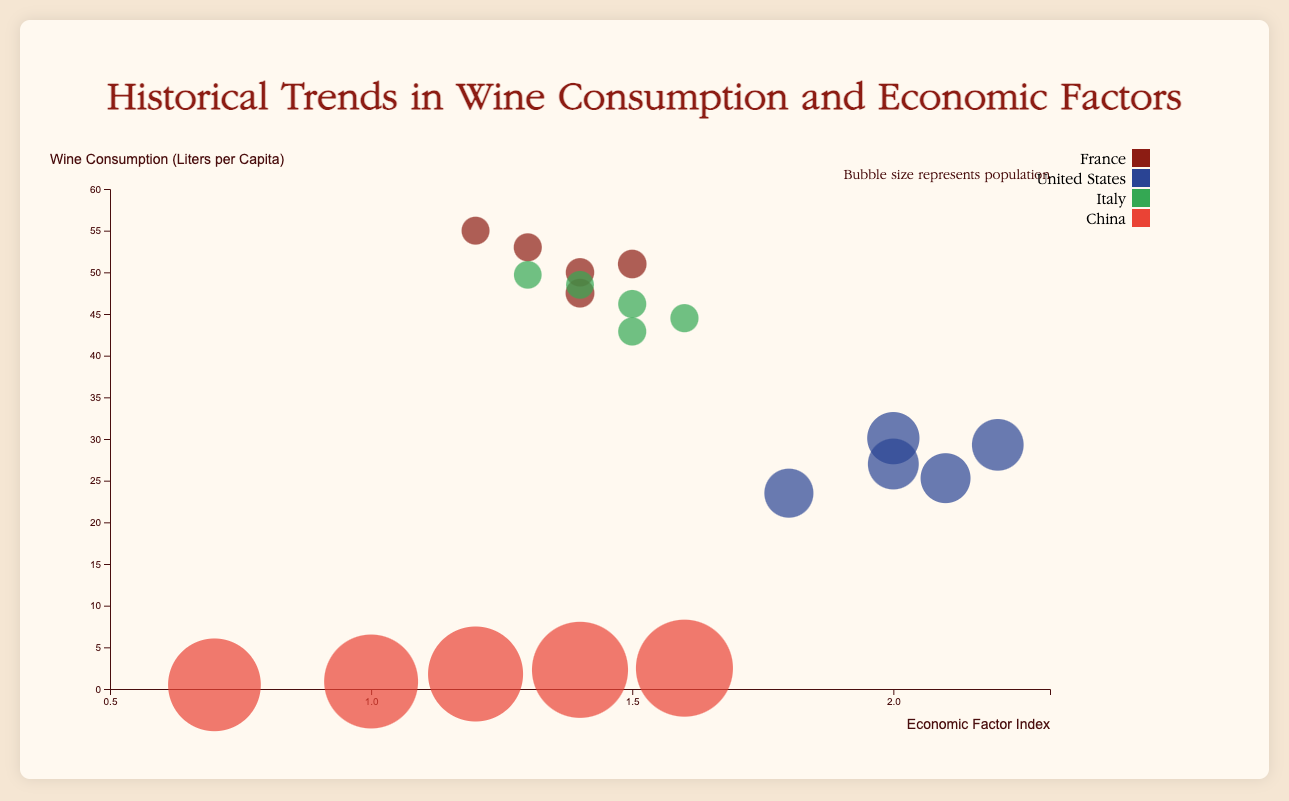What is the title of the chart? The title of the chart is displayed at the top and it reads "Historical Trends in Wine Consumption and Economic Factors".
Answer: Historical Trends in Wine Consumption and Economic Factors Which country had the highest wine consumption in the year 2000? From the chart, the data point with the highest y-value in 2000 belongs to France.
Answer: France What does the size of the bubbles represent in the chart? The legend in the top right indicates that the size of the bubbles represents the population in millions.
Answer: Population Over the years from 2000 to 2020, which country shows a consistent increase in the Economic Factor Index? Examining the x-axis positions of the bubbles for each country over the years, only China's bubbles consistently move to the right, indicating a steady increase in the Economic Factor Index.
Answer: China Which country had the lowest wine consumption in 2010? In the year 2010, the lowest y-value data point corresponds to China.
Answer: China Compare the wine consumption of France and Italy in 2015. Which country consumed more wine per capita? Looking at the y-values for 2015, France's bubble is higher than Italy's, indicating that France consumed more wine per capita.
Answer: France How did the wine consumption in the United States change from 2000 to 2020? To determine the change in wine consumption, compare the y-values of the United States' bubbles between 2000 and 2020. The bubbles move upward from 23.5 liters in 2000 to 30.1 liters in 2020, showing an increase.
Answer: Increase Which country had the largest population in 2020 and how is this visually represented on the chart? The largest bubble size in 2020 represents population, and the largest bubble belongs to China.
Answer: China What correlation can be observed between Economic Factor Index and Wine Consumption for France over the years? For France, as we observe bubbles from 2000 to 2020, a slight downward trend in y-values (wine consumption) is seen despite an increase in x-values (Economic Factor Index) up till 2015, followed by a decrease. This suggests a weak or inverse correlation.
Answer: Inverse correlation What was the wine consumption difference between Italy and China in 2005? In 2005, the y-value for Italy is 48.5 liters and for China is 0.9 liters. The difference is 48.5 - 0.9 = 47.6 liters.
Answer: 47.6 liters 